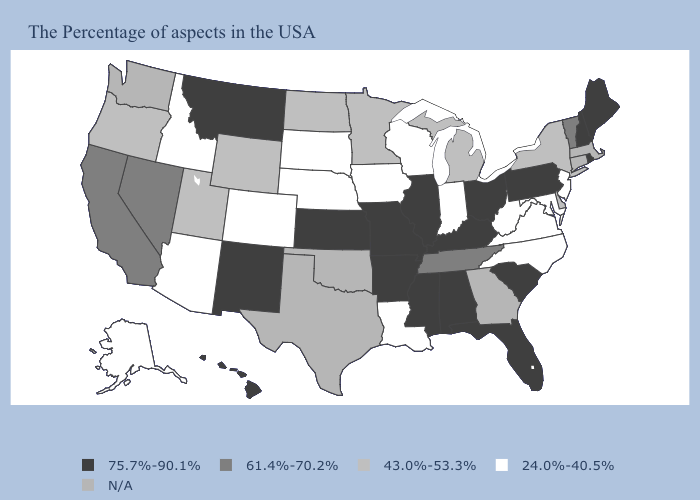Among the states that border Virginia , which have the lowest value?
Be succinct. Maryland, North Carolina, West Virginia. Name the states that have a value in the range 61.4%-70.2%?
Give a very brief answer. Vermont, Tennessee, Nevada, California. Name the states that have a value in the range 43.0%-53.3%?
Short answer required. New York, Delaware, Michigan, Minnesota, North Dakota, Wyoming, Utah, Oregon. Name the states that have a value in the range 75.7%-90.1%?
Give a very brief answer. Maine, Rhode Island, New Hampshire, Pennsylvania, South Carolina, Ohio, Florida, Kentucky, Alabama, Illinois, Mississippi, Missouri, Arkansas, Kansas, New Mexico, Montana, Hawaii. What is the value of Alaska?
Short answer required. 24.0%-40.5%. How many symbols are there in the legend?
Answer briefly. 5. What is the lowest value in states that border Mississippi?
Be succinct. 24.0%-40.5%. Does Kentucky have the highest value in the USA?
Give a very brief answer. Yes. Is the legend a continuous bar?
Short answer required. No. What is the value of Texas?
Write a very short answer. N/A. Name the states that have a value in the range N/A?
Answer briefly. Massachusetts, Connecticut, Georgia, Oklahoma, Texas, Washington. Is the legend a continuous bar?
Be succinct. No. Which states have the lowest value in the USA?
Concise answer only. New Jersey, Maryland, Virginia, North Carolina, West Virginia, Indiana, Wisconsin, Louisiana, Iowa, Nebraska, South Dakota, Colorado, Arizona, Idaho, Alaska. Does Illinois have the lowest value in the USA?
Short answer required. No. 